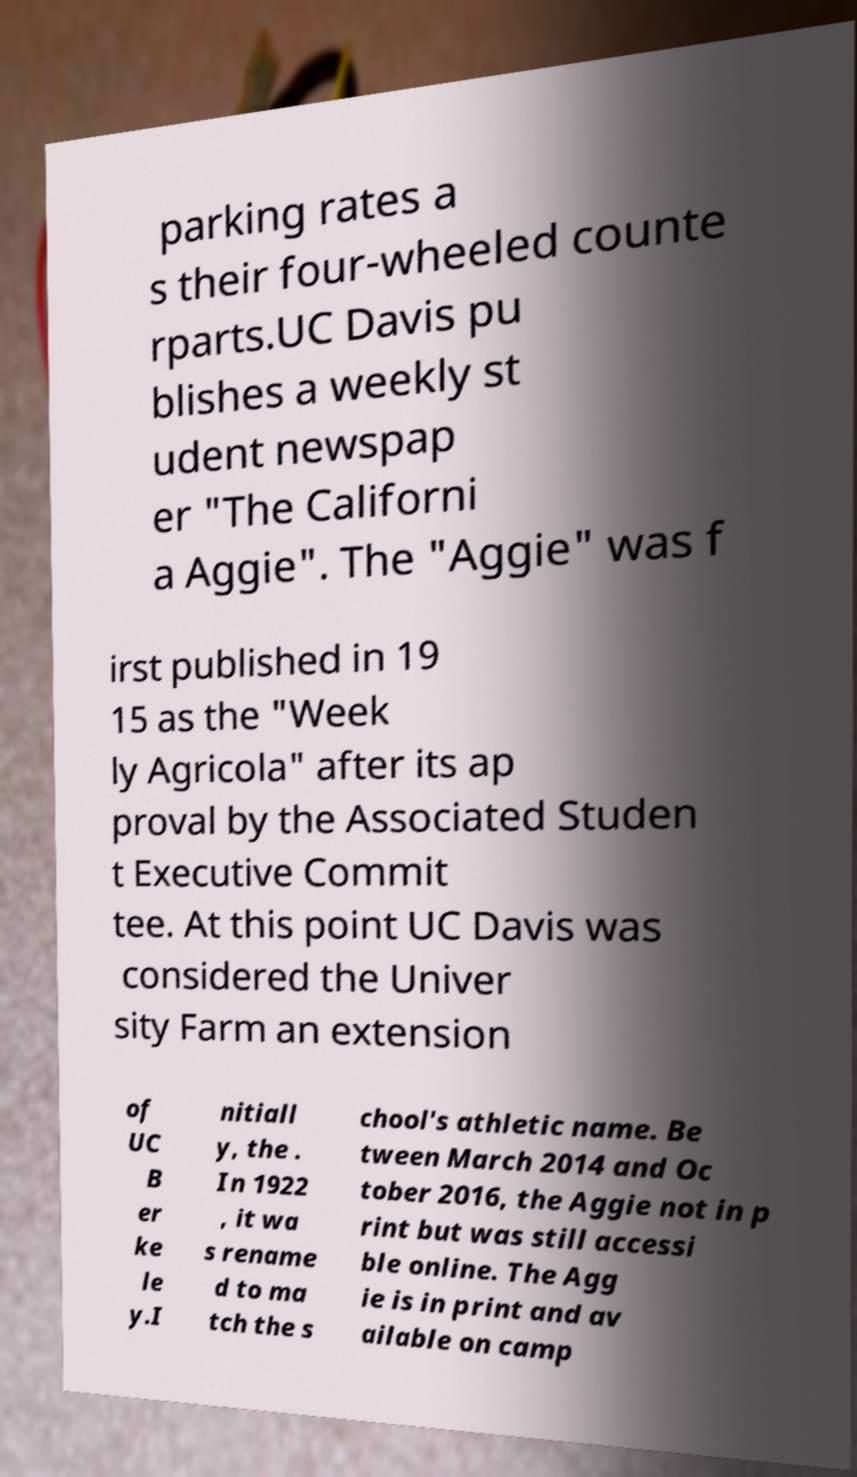Can you read and provide the text displayed in the image?This photo seems to have some interesting text. Can you extract and type it out for me? parking rates a s their four-wheeled counte rparts.UC Davis pu blishes a weekly st udent newspap er "The Californi a Aggie". The "Aggie" was f irst published in 19 15 as the "Week ly Agricola" after its ap proval by the Associated Studen t Executive Commit tee. At this point UC Davis was considered the Univer sity Farm an extension of UC B er ke le y.I nitiall y, the . In 1922 , it wa s rename d to ma tch the s chool's athletic name. Be tween March 2014 and Oc tober 2016, the Aggie not in p rint but was still accessi ble online. The Agg ie is in print and av ailable on camp 